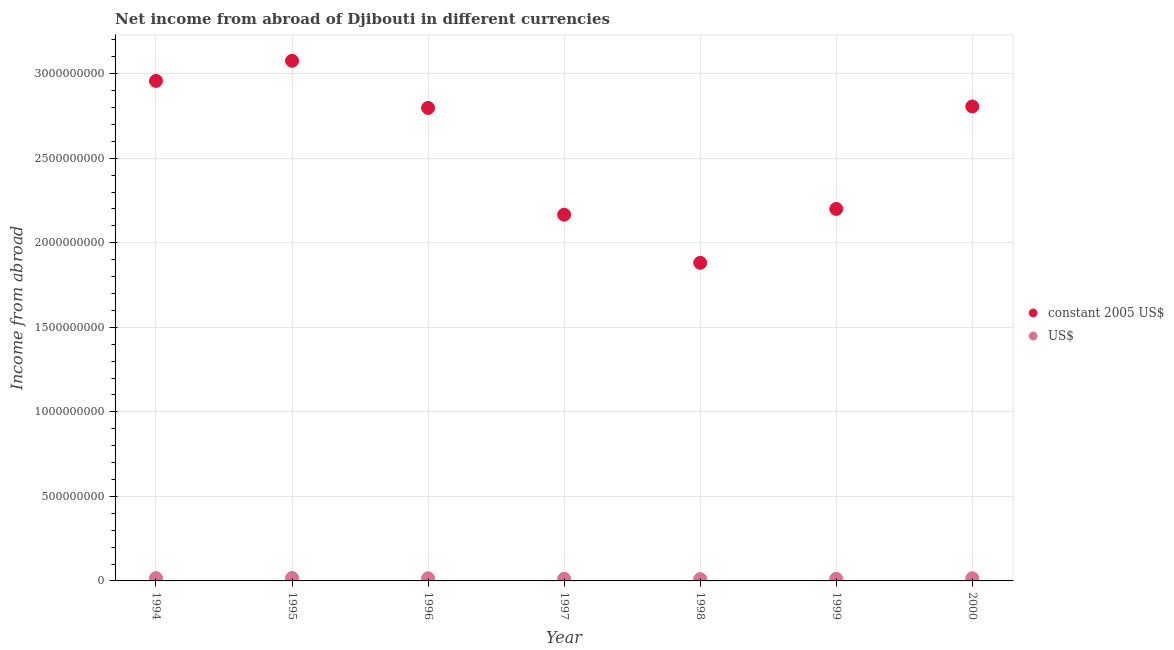How many different coloured dotlines are there?
Ensure brevity in your answer.  2. Is the number of dotlines equal to the number of legend labels?
Ensure brevity in your answer.  Yes. What is the income from abroad in us$ in 1997?
Your response must be concise. 1.22e+07. Across all years, what is the maximum income from abroad in constant 2005 us$?
Make the answer very short. 3.08e+09. Across all years, what is the minimum income from abroad in constant 2005 us$?
Keep it short and to the point. 1.88e+09. What is the total income from abroad in constant 2005 us$ in the graph?
Make the answer very short. 1.79e+1. What is the difference between the income from abroad in constant 2005 us$ in 1997 and that in 2000?
Ensure brevity in your answer.  -6.40e+08. What is the difference between the income from abroad in constant 2005 us$ in 1999 and the income from abroad in us$ in 2000?
Ensure brevity in your answer.  2.18e+09. What is the average income from abroad in constant 2005 us$ per year?
Offer a terse response. 2.55e+09. In the year 1994, what is the difference between the income from abroad in us$ and income from abroad in constant 2005 us$?
Your answer should be very brief. -2.94e+09. What is the ratio of the income from abroad in us$ in 1995 to that in 2000?
Make the answer very short. 1.1. Is the income from abroad in us$ in 1997 less than that in 2000?
Your answer should be very brief. Yes. What is the difference between the highest and the second highest income from abroad in constant 2005 us$?
Give a very brief answer. 1.19e+08. What is the difference between the highest and the lowest income from abroad in us$?
Offer a terse response. 6.72e+06. Does the income from abroad in constant 2005 us$ monotonically increase over the years?
Your response must be concise. No. Is the income from abroad in us$ strictly less than the income from abroad in constant 2005 us$ over the years?
Provide a succinct answer. Yes. How many dotlines are there?
Provide a succinct answer. 2. Are the values on the major ticks of Y-axis written in scientific E-notation?
Offer a terse response. No. Does the graph contain grids?
Your response must be concise. Yes. Where does the legend appear in the graph?
Offer a very short reply. Center right. What is the title of the graph?
Your answer should be compact. Net income from abroad of Djibouti in different currencies. Does "Ages 15-24" appear as one of the legend labels in the graph?
Keep it short and to the point. No. What is the label or title of the X-axis?
Your answer should be compact. Year. What is the label or title of the Y-axis?
Provide a short and direct response. Income from abroad. What is the Income from abroad in constant 2005 US$ in 1994?
Offer a terse response. 2.96e+09. What is the Income from abroad in US$ in 1994?
Ensure brevity in your answer.  1.66e+07. What is the Income from abroad of constant 2005 US$ in 1995?
Offer a terse response. 3.08e+09. What is the Income from abroad in US$ in 1995?
Provide a succinct answer. 1.73e+07. What is the Income from abroad in constant 2005 US$ in 1996?
Offer a terse response. 2.80e+09. What is the Income from abroad in US$ in 1996?
Ensure brevity in your answer.  1.57e+07. What is the Income from abroad in constant 2005 US$ in 1997?
Keep it short and to the point. 2.17e+09. What is the Income from abroad in US$ in 1997?
Make the answer very short. 1.22e+07. What is the Income from abroad in constant 2005 US$ in 1998?
Offer a terse response. 1.88e+09. What is the Income from abroad of US$ in 1998?
Your answer should be very brief. 1.06e+07. What is the Income from abroad in constant 2005 US$ in 1999?
Offer a very short reply. 2.20e+09. What is the Income from abroad of US$ in 1999?
Your answer should be compact. 1.24e+07. What is the Income from abroad of constant 2005 US$ in 2000?
Provide a short and direct response. 2.81e+09. What is the Income from abroad in US$ in 2000?
Offer a terse response. 1.58e+07. Across all years, what is the maximum Income from abroad of constant 2005 US$?
Your answer should be compact. 3.08e+09. Across all years, what is the maximum Income from abroad of US$?
Your answer should be compact. 1.73e+07. Across all years, what is the minimum Income from abroad in constant 2005 US$?
Your response must be concise. 1.88e+09. Across all years, what is the minimum Income from abroad of US$?
Your response must be concise. 1.06e+07. What is the total Income from abroad in constant 2005 US$ in the graph?
Make the answer very short. 1.79e+1. What is the total Income from abroad of US$ in the graph?
Offer a very short reply. 1.01e+08. What is the difference between the Income from abroad of constant 2005 US$ in 1994 and that in 1995?
Provide a short and direct response. -1.19e+08. What is the difference between the Income from abroad of US$ in 1994 and that in 1995?
Offer a very short reply. -6.69e+05. What is the difference between the Income from abroad of constant 2005 US$ in 1994 and that in 1996?
Provide a short and direct response. 1.60e+08. What is the difference between the Income from abroad of US$ in 1994 and that in 1996?
Offer a very short reply. 8.99e+05. What is the difference between the Income from abroad of constant 2005 US$ in 1994 and that in 1997?
Keep it short and to the point. 7.91e+08. What is the difference between the Income from abroad of US$ in 1994 and that in 1997?
Give a very brief answer. 4.45e+06. What is the difference between the Income from abroad of constant 2005 US$ in 1994 and that in 1998?
Your answer should be compact. 1.08e+09. What is the difference between the Income from abroad of US$ in 1994 and that in 1998?
Your answer should be compact. 6.05e+06. What is the difference between the Income from abroad of constant 2005 US$ in 1994 and that in 1999?
Provide a short and direct response. 7.57e+08. What is the difference between the Income from abroad of US$ in 1994 and that in 1999?
Offer a terse response. 4.26e+06. What is the difference between the Income from abroad of constant 2005 US$ in 1994 and that in 2000?
Make the answer very short. 1.51e+08. What is the difference between the Income from abroad in US$ in 1994 and that in 2000?
Offer a terse response. 8.51e+05. What is the difference between the Income from abroad of constant 2005 US$ in 1995 and that in 1996?
Ensure brevity in your answer.  2.79e+08. What is the difference between the Income from abroad of US$ in 1995 and that in 1996?
Make the answer very short. 1.57e+06. What is the difference between the Income from abroad of constant 2005 US$ in 1995 and that in 1997?
Offer a very short reply. 9.10e+08. What is the difference between the Income from abroad in US$ in 1995 and that in 1997?
Your answer should be very brief. 5.12e+06. What is the difference between the Income from abroad in constant 2005 US$ in 1995 and that in 1998?
Keep it short and to the point. 1.19e+09. What is the difference between the Income from abroad in US$ in 1995 and that in 1998?
Provide a succinct answer. 6.72e+06. What is the difference between the Income from abroad in constant 2005 US$ in 1995 and that in 1999?
Give a very brief answer. 8.76e+08. What is the difference between the Income from abroad of US$ in 1995 and that in 1999?
Provide a succinct answer. 4.93e+06. What is the difference between the Income from abroad in constant 2005 US$ in 1995 and that in 2000?
Give a very brief answer. 2.70e+08. What is the difference between the Income from abroad of US$ in 1995 and that in 2000?
Offer a terse response. 1.52e+06. What is the difference between the Income from abroad in constant 2005 US$ in 1996 and that in 1997?
Provide a succinct answer. 6.31e+08. What is the difference between the Income from abroad in US$ in 1996 and that in 1997?
Offer a terse response. 3.55e+06. What is the difference between the Income from abroad of constant 2005 US$ in 1996 and that in 1998?
Your response must be concise. 9.16e+08. What is the difference between the Income from abroad in US$ in 1996 and that in 1998?
Make the answer very short. 5.15e+06. What is the difference between the Income from abroad in constant 2005 US$ in 1996 and that in 1999?
Provide a short and direct response. 5.97e+08. What is the difference between the Income from abroad in US$ in 1996 and that in 1999?
Provide a short and direct response. 3.36e+06. What is the difference between the Income from abroad in constant 2005 US$ in 1996 and that in 2000?
Give a very brief answer. -8.66e+06. What is the difference between the Income from abroad in US$ in 1996 and that in 2000?
Provide a short and direct response. -4.87e+04. What is the difference between the Income from abroad in constant 2005 US$ in 1997 and that in 1998?
Ensure brevity in your answer.  2.85e+08. What is the difference between the Income from abroad of US$ in 1997 and that in 1998?
Provide a short and direct response. 1.60e+06. What is the difference between the Income from abroad of constant 2005 US$ in 1997 and that in 1999?
Provide a short and direct response. -3.42e+07. What is the difference between the Income from abroad of US$ in 1997 and that in 1999?
Offer a terse response. -1.92e+05. What is the difference between the Income from abroad in constant 2005 US$ in 1997 and that in 2000?
Provide a short and direct response. -6.40e+08. What is the difference between the Income from abroad of US$ in 1997 and that in 2000?
Ensure brevity in your answer.  -3.60e+06. What is the difference between the Income from abroad of constant 2005 US$ in 1998 and that in 1999?
Keep it short and to the point. -3.19e+08. What is the difference between the Income from abroad of US$ in 1998 and that in 1999?
Offer a very short reply. -1.79e+06. What is the difference between the Income from abroad of constant 2005 US$ in 1998 and that in 2000?
Give a very brief answer. -9.25e+08. What is the difference between the Income from abroad in US$ in 1998 and that in 2000?
Your response must be concise. -5.20e+06. What is the difference between the Income from abroad of constant 2005 US$ in 1999 and that in 2000?
Provide a short and direct response. -6.06e+08. What is the difference between the Income from abroad in US$ in 1999 and that in 2000?
Make the answer very short. -3.41e+06. What is the difference between the Income from abroad of constant 2005 US$ in 1994 and the Income from abroad of US$ in 1995?
Your answer should be compact. 2.94e+09. What is the difference between the Income from abroad of constant 2005 US$ in 1994 and the Income from abroad of US$ in 1996?
Give a very brief answer. 2.94e+09. What is the difference between the Income from abroad of constant 2005 US$ in 1994 and the Income from abroad of US$ in 1997?
Give a very brief answer. 2.94e+09. What is the difference between the Income from abroad in constant 2005 US$ in 1994 and the Income from abroad in US$ in 1998?
Ensure brevity in your answer.  2.95e+09. What is the difference between the Income from abroad in constant 2005 US$ in 1994 and the Income from abroad in US$ in 1999?
Offer a terse response. 2.94e+09. What is the difference between the Income from abroad in constant 2005 US$ in 1994 and the Income from abroad in US$ in 2000?
Keep it short and to the point. 2.94e+09. What is the difference between the Income from abroad of constant 2005 US$ in 1995 and the Income from abroad of US$ in 1996?
Give a very brief answer. 3.06e+09. What is the difference between the Income from abroad of constant 2005 US$ in 1995 and the Income from abroad of US$ in 1997?
Your response must be concise. 3.06e+09. What is the difference between the Income from abroad of constant 2005 US$ in 1995 and the Income from abroad of US$ in 1998?
Offer a very short reply. 3.07e+09. What is the difference between the Income from abroad in constant 2005 US$ in 1995 and the Income from abroad in US$ in 1999?
Provide a succinct answer. 3.06e+09. What is the difference between the Income from abroad of constant 2005 US$ in 1995 and the Income from abroad of US$ in 2000?
Offer a very short reply. 3.06e+09. What is the difference between the Income from abroad of constant 2005 US$ in 1996 and the Income from abroad of US$ in 1997?
Provide a short and direct response. 2.79e+09. What is the difference between the Income from abroad of constant 2005 US$ in 1996 and the Income from abroad of US$ in 1998?
Provide a succinct answer. 2.79e+09. What is the difference between the Income from abroad of constant 2005 US$ in 1996 and the Income from abroad of US$ in 1999?
Your response must be concise. 2.78e+09. What is the difference between the Income from abroad of constant 2005 US$ in 1996 and the Income from abroad of US$ in 2000?
Your answer should be compact. 2.78e+09. What is the difference between the Income from abroad of constant 2005 US$ in 1997 and the Income from abroad of US$ in 1998?
Provide a short and direct response. 2.16e+09. What is the difference between the Income from abroad in constant 2005 US$ in 1997 and the Income from abroad in US$ in 1999?
Your answer should be very brief. 2.15e+09. What is the difference between the Income from abroad of constant 2005 US$ in 1997 and the Income from abroad of US$ in 2000?
Your response must be concise. 2.15e+09. What is the difference between the Income from abroad of constant 2005 US$ in 1998 and the Income from abroad of US$ in 1999?
Keep it short and to the point. 1.87e+09. What is the difference between the Income from abroad of constant 2005 US$ in 1998 and the Income from abroad of US$ in 2000?
Make the answer very short. 1.87e+09. What is the difference between the Income from abroad of constant 2005 US$ in 1999 and the Income from abroad of US$ in 2000?
Provide a short and direct response. 2.18e+09. What is the average Income from abroad in constant 2005 US$ per year?
Your answer should be compact. 2.55e+09. What is the average Income from abroad of US$ per year?
Offer a terse response. 1.44e+07. In the year 1994, what is the difference between the Income from abroad in constant 2005 US$ and Income from abroad in US$?
Your answer should be very brief. 2.94e+09. In the year 1995, what is the difference between the Income from abroad in constant 2005 US$ and Income from abroad in US$?
Your answer should be compact. 3.06e+09. In the year 1996, what is the difference between the Income from abroad in constant 2005 US$ and Income from abroad in US$?
Give a very brief answer. 2.78e+09. In the year 1997, what is the difference between the Income from abroad of constant 2005 US$ and Income from abroad of US$?
Your answer should be compact. 2.15e+09. In the year 1998, what is the difference between the Income from abroad in constant 2005 US$ and Income from abroad in US$?
Offer a terse response. 1.87e+09. In the year 1999, what is the difference between the Income from abroad in constant 2005 US$ and Income from abroad in US$?
Offer a terse response. 2.19e+09. In the year 2000, what is the difference between the Income from abroad of constant 2005 US$ and Income from abroad of US$?
Keep it short and to the point. 2.79e+09. What is the ratio of the Income from abroad in constant 2005 US$ in 1994 to that in 1995?
Ensure brevity in your answer.  0.96. What is the ratio of the Income from abroad of US$ in 1994 to that in 1995?
Your answer should be very brief. 0.96. What is the ratio of the Income from abroad of constant 2005 US$ in 1994 to that in 1996?
Ensure brevity in your answer.  1.06. What is the ratio of the Income from abroad in US$ in 1994 to that in 1996?
Your response must be concise. 1.06. What is the ratio of the Income from abroad in constant 2005 US$ in 1994 to that in 1997?
Provide a short and direct response. 1.37. What is the ratio of the Income from abroad of US$ in 1994 to that in 1997?
Your response must be concise. 1.37. What is the ratio of the Income from abroad in constant 2005 US$ in 1994 to that in 1998?
Your response must be concise. 1.57. What is the ratio of the Income from abroad in US$ in 1994 to that in 1998?
Your answer should be very brief. 1.57. What is the ratio of the Income from abroad of constant 2005 US$ in 1994 to that in 1999?
Ensure brevity in your answer.  1.34. What is the ratio of the Income from abroad in US$ in 1994 to that in 1999?
Your response must be concise. 1.34. What is the ratio of the Income from abroad of constant 2005 US$ in 1994 to that in 2000?
Give a very brief answer. 1.05. What is the ratio of the Income from abroad of US$ in 1994 to that in 2000?
Offer a terse response. 1.05. What is the ratio of the Income from abroad in constant 2005 US$ in 1995 to that in 1996?
Offer a very short reply. 1.1. What is the ratio of the Income from abroad of US$ in 1995 to that in 1996?
Provide a succinct answer. 1.1. What is the ratio of the Income from abroad of constant 2005 US$ in 1995 to that in 1997?
Your response must be concise. 1.42. What is the ratio of the Income from abroad of US$ in 1995 to that in 1997?
Your answer should be compact. 1.42. What is the ratio of the Income from abroad of constant 2005 US$ in 1995 to that in 1998?
Offer a very short reply. 1.64. What is the ratio of the Income from abroad in US$ in 1995 to that in 1998?
Your response must be concise. 1.64. What is the ratio of the Income from abroad of constant 2005 US$ in 1995 to that in 1999?
Provide a short and direct response. 1.4. What is the ratio of the Income from abroad in US$ in 1995 to that in 1999?
Your response must be concise. 1.4. What is the ratio of the Income from abroad in constant 2005 US$ in 1995 to that in 2000?
Make the answer very short. 1.1. What is the ratio of the Income from abroad of US$ in 1995 to that in 2000?
Keep it short and to the point. 1.1. What is the ratio of the Income from abroad of constant 2005 US$ in 1996 to that in 1997?
Your answer should be compact. 1.29. What is the ratio of the Income from abroad of US$ in 1996 to that in 1997?
Offer a very short reply. 1.29. What is the ratio of the Income from abroad in constant 2005 US$ in 1996 to that in 1998?
Ensure brevity in your answer.  1.49. What is the ratio of the Income from abroad in US$ in 1996 to that in 1998?
Make the answer very short. 1.49. What is the ratio of the Income from abroad of constant 2005 US$ in 1996 to that in 1999?
Ensure brevity in your answer.  1.27. What is the ratio of the Income from abroad of US$ in 1996 to that in 1999?
Keep it short and to the point. 1.27. What is the ratio of the Income from abroad of constant 2005 US$ in 1996 to that in 2000?
Your answer should be compact. 1. What is the ratio of the Income from abroad in constant 2005 US$ in 1997 to that in 1998?
Your answer should be compact. 1.15. What is the ratio of the Income from abroad in US$ in 1997 to that in 1998?
Make the answer very short. 1.15. What is the ratio of the Income from abroad in constant 2005 US$ in 1997 to that in 1999?
Provide a succinct answer. 0.98. What is the ratio of the Income from abroad in US$ in 1997 to that in 1999?
Offer a very short reply. 0.98. What is the ratio of the Income from abroad of constant 2005 US$ in 1997 to that in 2000?
Ensure brevity in your answer.  0.77. What is the ratio of the Income from abroad in US$ in 1997 to that in 2000?
Your answer should be very brief. 0.77. What is the ratio of the Income from abroad of constant 2005 US$ in 1998 to that in 1999?
Make the answer very short. 0.86. What is the ratio of the Income from abroad of US$ in 1998 to that in 1999?
Ensure brevity in your answer.  0.86. What is the ratio of the Income from abroad of constant 2005 US$ in 1998 to that in 2000?
Ensure brevity in your answer.  0.67. What is the ratio of the Income from abroad in US$ in 1998 to that in 2000?
Make the answer very short. 0.67. What is the ratio of the Income from abroad of constant 2005 US$ in 1999 to that in 2000?
Provide a succinct answer. 0.78. What is the ratio of the Income from abroad in US$ in 1999 to that in 2000?
Keep it short and to the point. 0.78. What is the difference between the highest and the second highest Income from abroad in constant 2005 US$?
Provide a short and direct response. 1.19e+08. What is the difference between the highest and the second highest Income from abroad of US$?
Provide a succinct answer. 6.69e+05. What is the difference between the highest and the lowest Income from abroad in constant 2005 US$?
Keep it short and to the point. 1.19e+09. What is the difference between the highest and the lowest Income from abroad in US$?
Provide a succinct answer. 6.72e+06. 